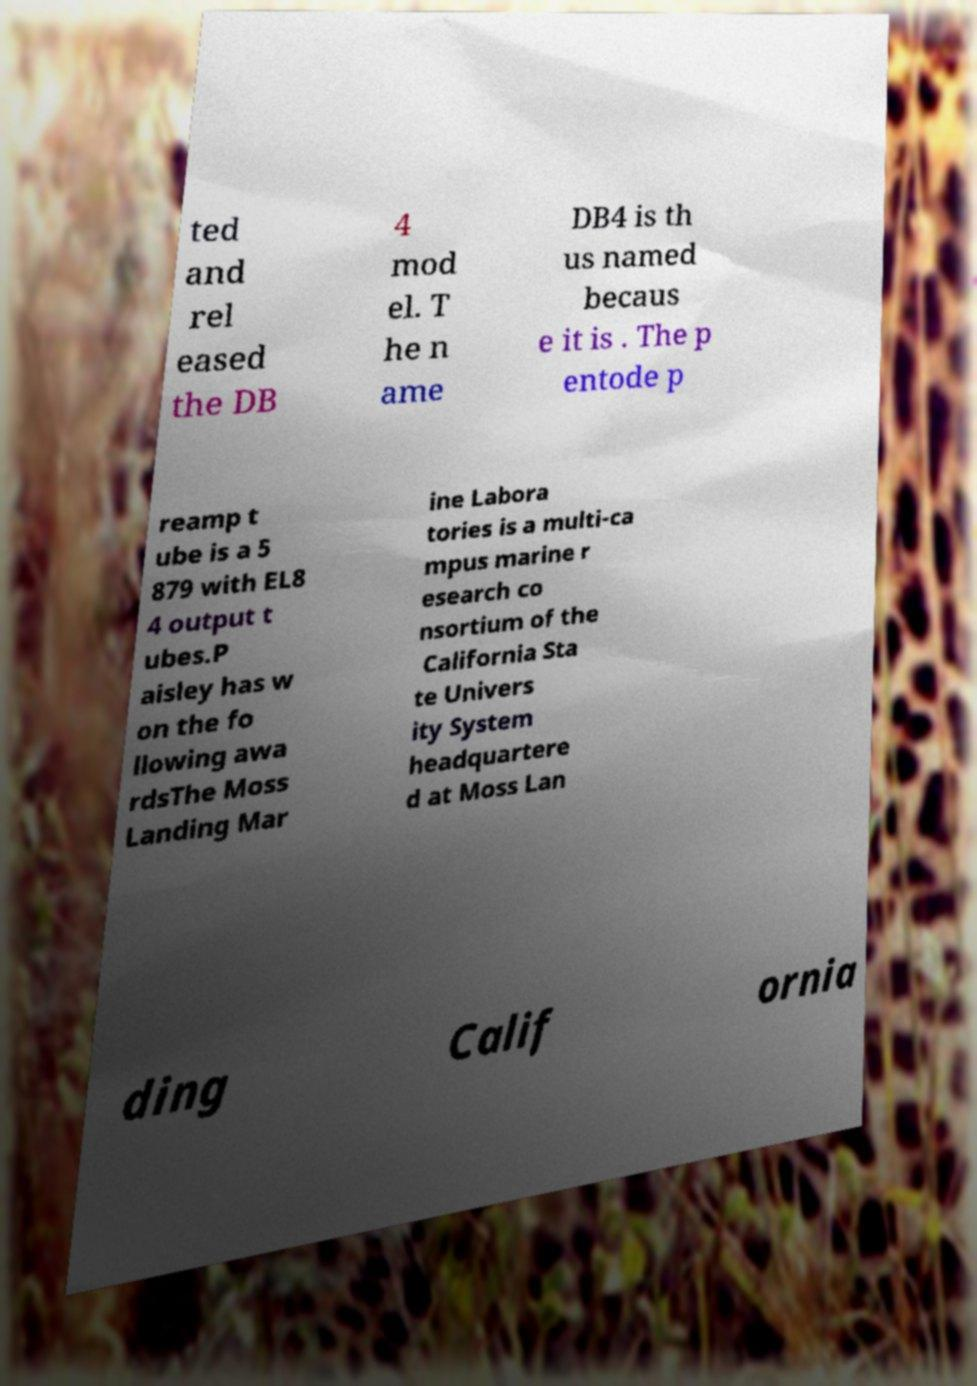Could you extract and type out the text from this image? ted and rel eased the DB 4 mod el. T he n ame DB4 is th us named becaus e it is . The p entode p reamp t ube is a 5 879 with EL8 4 output t ubes.P aisley has w on the fo llowing awa rdsThe Moss Landing Mar ine Labora tories is a multi-ca mpus marine r esearch co nsortium of the California Sta te Univers ity System headquartere d at Moss Lan ding Calif ornia 